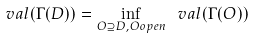Convert formula to latex. <formula><loc_0><loc_0><loc_500><loc_500>\ v a l ( \Gamma ( D ) ) = \inf _ { O \supseteq D , O o p e n } \ v a l ( \Gamma ( O ) )</formula> 